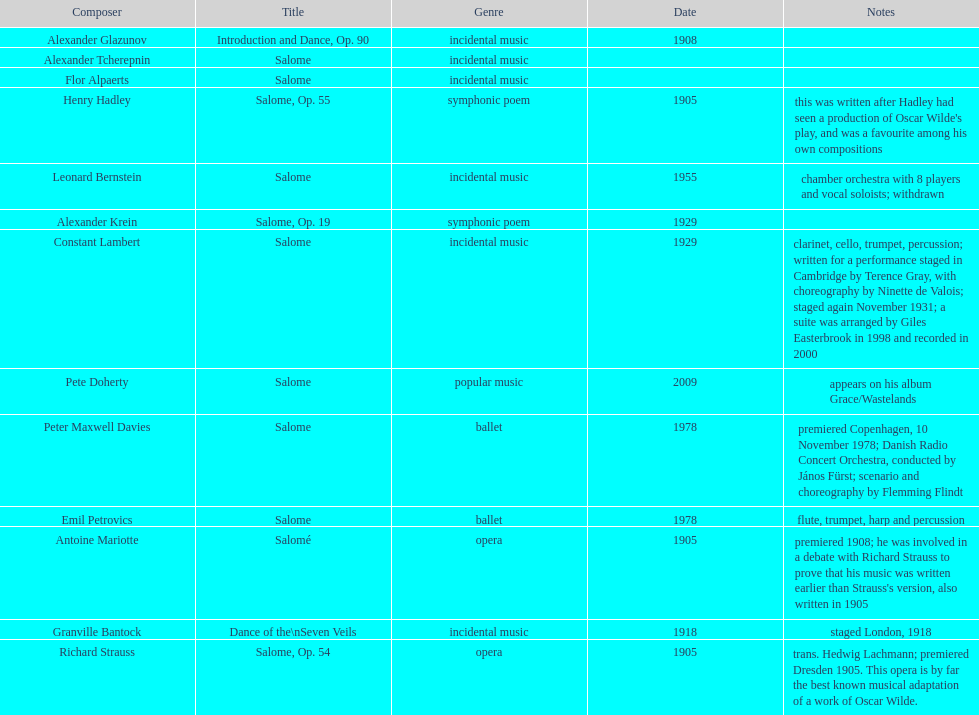What is the number of works titled "salome?" 11. 